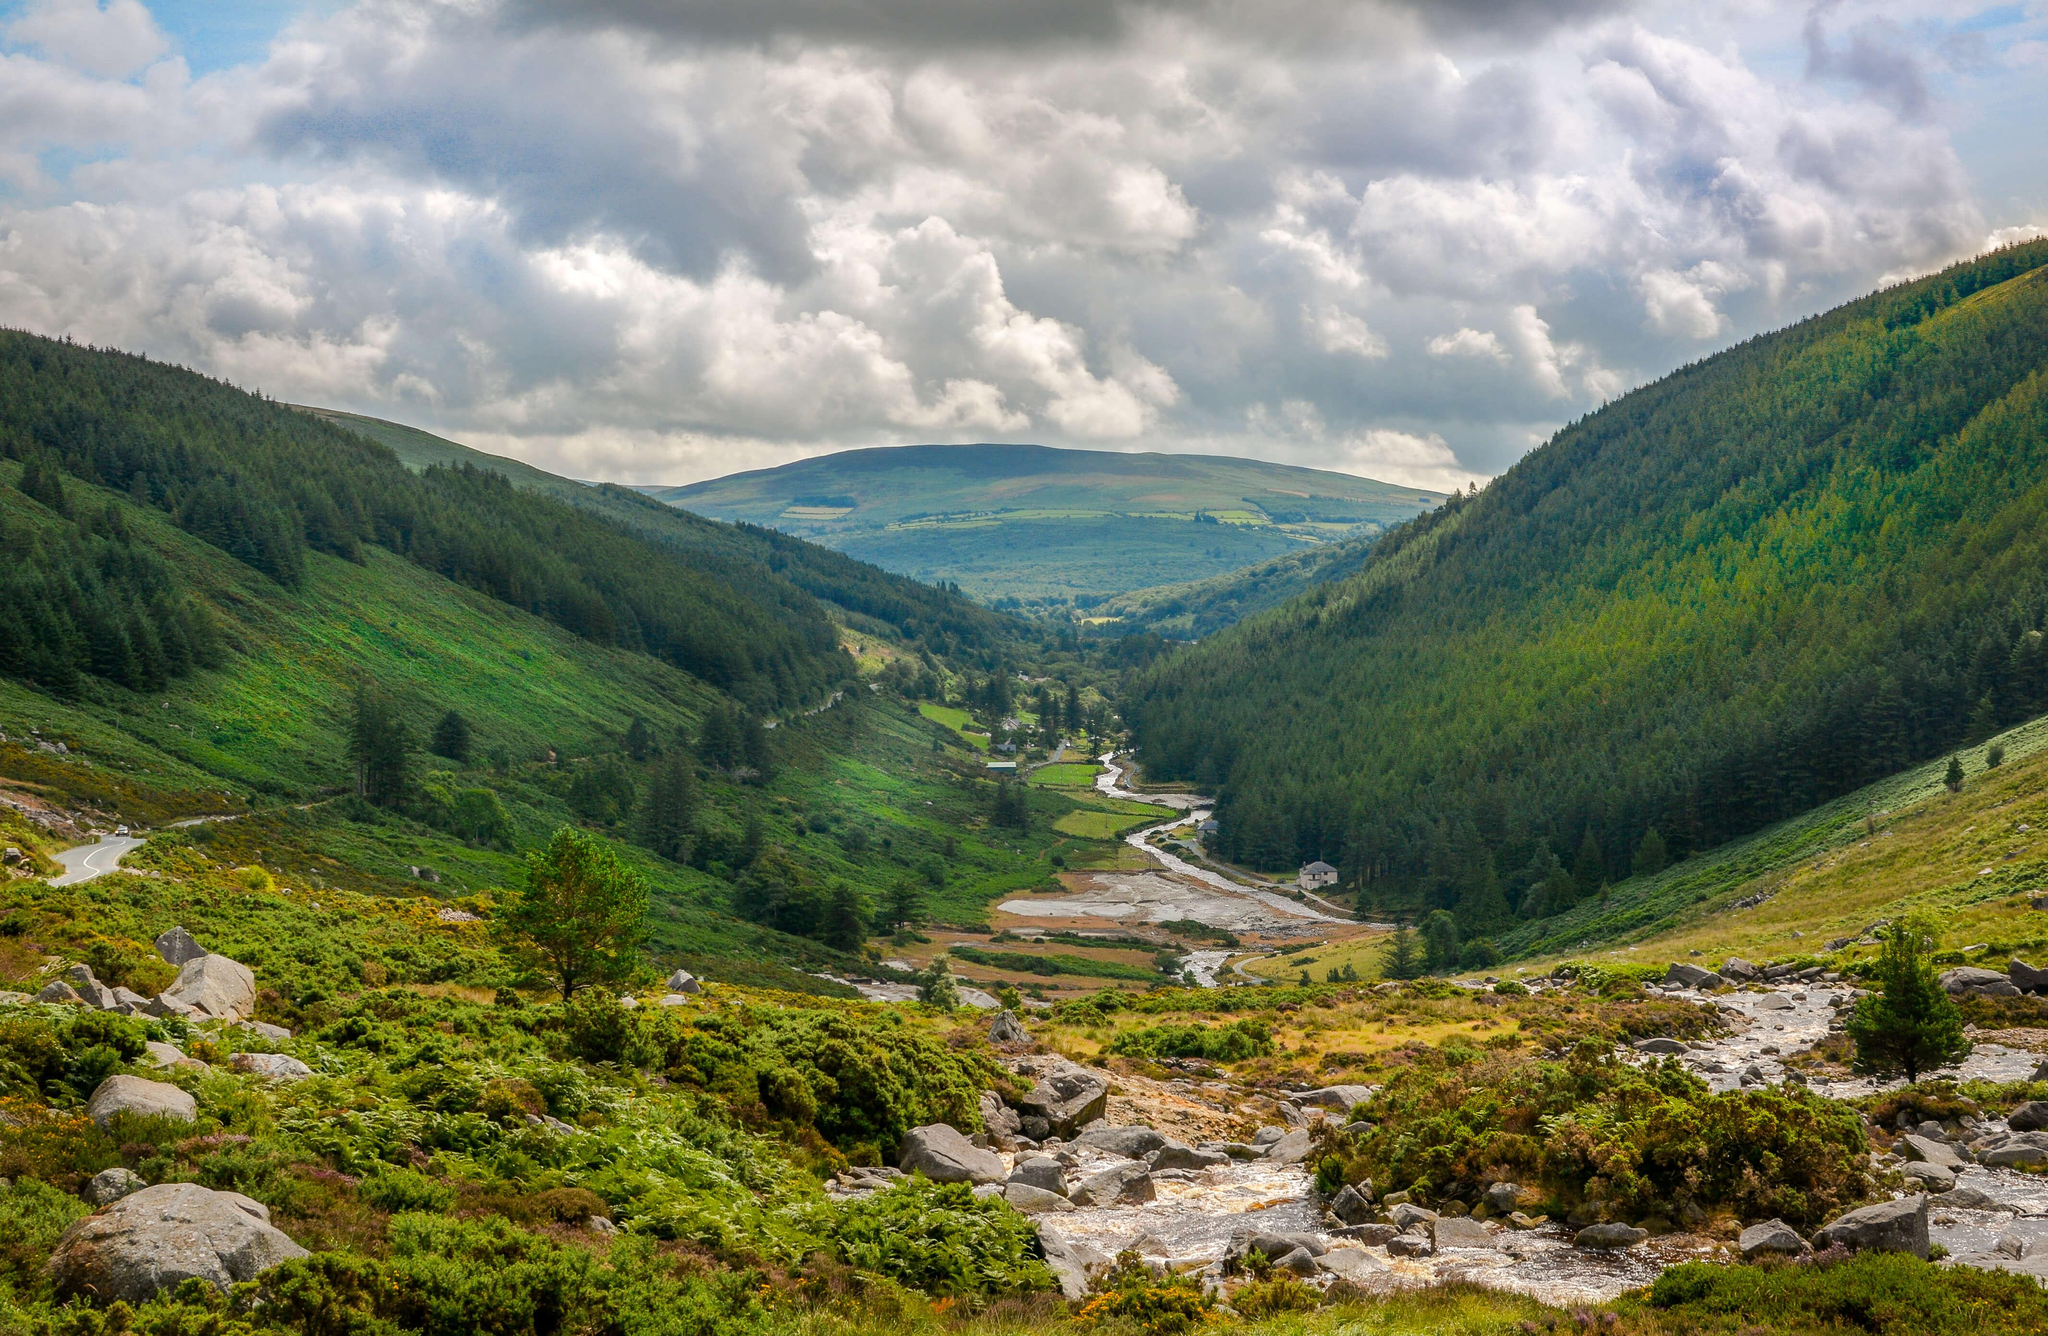Outline some significant characteristics in this image. The predominant color in the image is green. The image depicts either mountains or a city, and in the image, it is clear that the dominant feature is the mountains. 